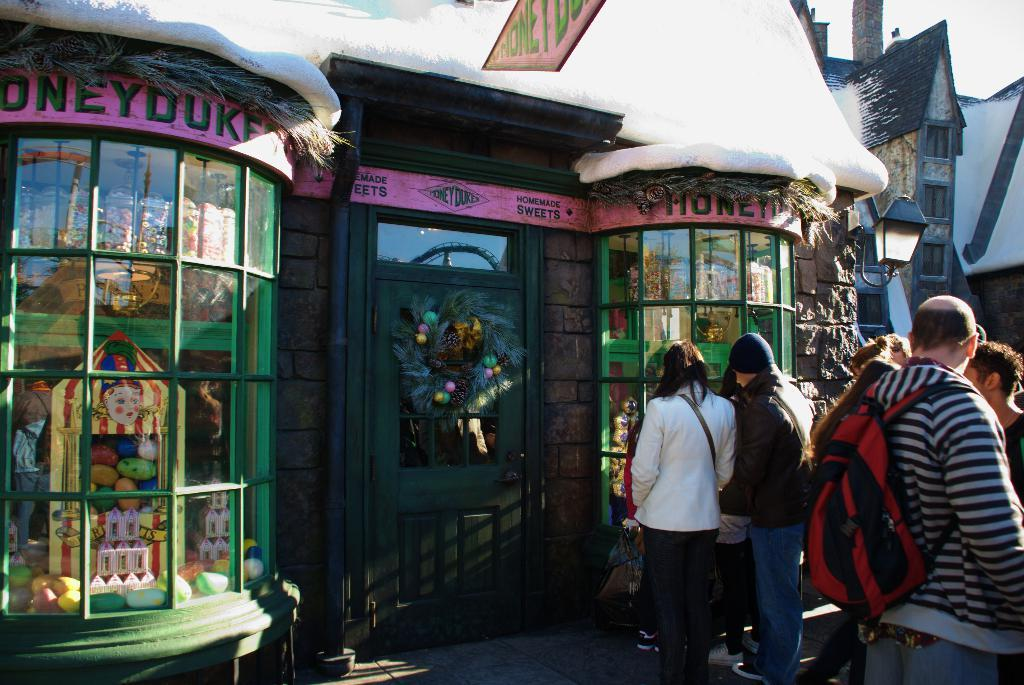What type of establishment is depicted in the image? There is a shop in the image. What decoration can be seen on the door of the shop? There is a garland on the door of the shop. Can you describe the lighting in the image? There is a light in the image. What items are visible inside the shop? There are toys inside the shop. What else is present in the image besides the shop? There is a group of people standing in the image, a building, and the sky is visible in the background. What type of oatmeal is being served at the lake in the image? There is no lake or oatmeal present in the image; it features a shop with a group of people standing outside. 